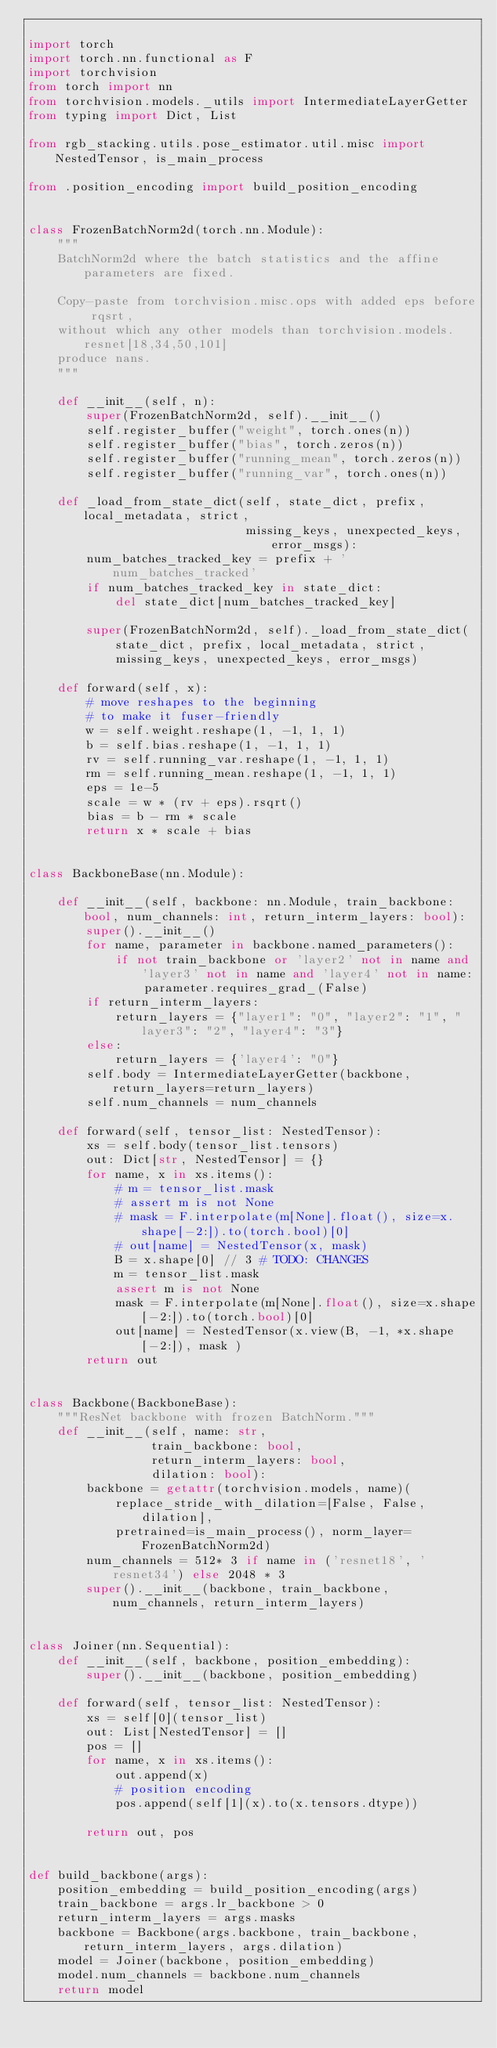Convert code to text. <code><loc_0><loc_0><loc_500><loc_500><_Python_>
import torch
import torch.nn.functional as F
import torchvision
from torch import nn
from torchvision.models._utils import IntermediateLayerGetter
from typing import Dict, List

from rgb_stacking.utils.pose_estimator.util.misc import NestedTensor, is_main_process

from .position_encoding import build_position_encoding


class FrozenBatchNorm2d(torch.nn.Module):
    """
    BatchNorm2d where the batch statistics and the affine parameters are fixed.

    Copy-paste from torchvision.misc.ops with added eps before rqsrt,
    without which any other models than torchvision.models.resnet[18,34,50,101]
    produce nans.
    """

    def __init__(self, n):
        super(FrozenBatchNorm2d, self).__init__()
        self.register_buffer("weight", torch.ones(n))
        self.register_buffer("bias", torch.zeros(n))
        self.register_buffer("running_mean", torch.zeros(n))
        self.register_buffer("running_var", torch.ones(n))

    def _load_from_state_dict(self, state_dict, prefix, local_metadata, strict,
                              missing_keys, unexpected_keys, error_msgs):
        num_batches_tracked_key = prefix + 'num_batches_tracked'
        if num_batches_tracked_key in state_dict:
            del state_dict[num_batches_tracked_key]

        super(FrozenBatchNorm2d, self)._load_from_state_dict(
            state_dict, prefix, local_metadata, strict,
            missing_keys, unexpected_keys, error_msgs)

    def forward(self, x):
        # move reshapes to the beginning
        # to make it fuser-friendly
        w = self.weight.reshape(1, -1, 1, 1)
        b = self.bias.reshape(1, -1, 1, 1)
        rv = self.running_var.reshape(1, -1, 1, 1)
        rm = self.running_mean.reshape(1, -1, 1, 1)
        eps = 1e-5
        scale = w * (rv + eps).rsqrt()
        bias = b - rm * scale
        return x * scale + bias


class BackboneBase(nn.Module):

    def __init__(self, backbone: nn.Module, train_backbone: bool, num_channels: int, return_interm_layers: bool):
        super().__init__()
        for name, parameter in backbone.named_parameters():
            if not train_backbone or 'layer2' not in name and 'layer3' not in name and 'layer4' not in name:
                parameter.requires_grad_(False)
        if return_interm_layers:
            return_layers = {"layer1": "0", "layer2": "1", "layer3": "2", "layer4": "3"}
        else:
            return_layers = {'layer4': "0"}
        self.body = IntermediateLayerGetter(backbone, return_layers=return_layers)
        self.num_channels = num_channels

    def forward(self, tensor_list: NestedTensor):
        xs = self.body(tensor_list.tensors)
        out: Dict[str, NestedTensor] = {}
        for name, x in xs.items():
            # m = tensor_list.mask
            # assert m is not None
            # mask = F.interpolate(m[None].float(), size=x.shape[-2:]).to(torch.bool)[0]
            # out[name] = NestedTensor(x, mask)
            B = x.shape[0] // 3 # TODO: CHANGES
            m = tensor_list.mask
            assert m is not None
            mask = F.interpolate(m[None].float(), size=x.shape[-2:]).to(torch.bool)[0]
            out[name] = NestedTensor(x.view(B, -1, *x.shape[-2:]), mask )
        return out


class Backbone(BackboneBase):
    """ResNet backbone with frozen BatchNorm."""
    def __init__(self, name: str,
                 train_backbone: bool,
                 return_interm_layers: bool,
                 dilation: bool):
        backbone = getattr(torchvision.models, name)(
            replace_stride_with_dilation=[False, False, dilation],
            pretrained=is_main_process(), norm_layer=FrozenBatchNorm2d)
        num_channels = 512* 3 if name in ('resnet18', 'resnet34') else 2048 * 3
        super().__init__(backbone, train_backbone, num_channels, return_interm_layers)


class Joiner(nn.Sequential):
    def __init__(self, backbone, position_embedding):
        super().__init__(backbone, position_embedding)

    def forward(self, tensor_list: NestedTensor):
        xs = self[0](tensor_list)
        out: List[NestedTensor] = []
        pos = []
        for name, x in xs.items():
            out.append(x)
            # position encoding
            pos.append(self[1](x).to(x.tensors.dtype))

        return out, pos


def build_backbone(args):
    position_embedding = build_position_encoding(args)
    train_backbone = args.lr_backbone > 0
    return_interm_layers = args.masks
    backbone = Backbone(args.backbone, train_backbone, return_interm_layers, args.dilation)
    model = Joiner(backbone, position_embedding)
    model.num_channels = backbone.num_channels
    return model
</code> 